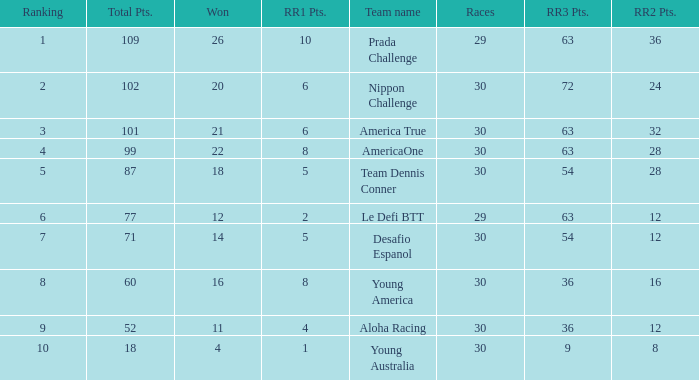Name the total number of rr2 pts for won being 11 1.0. 